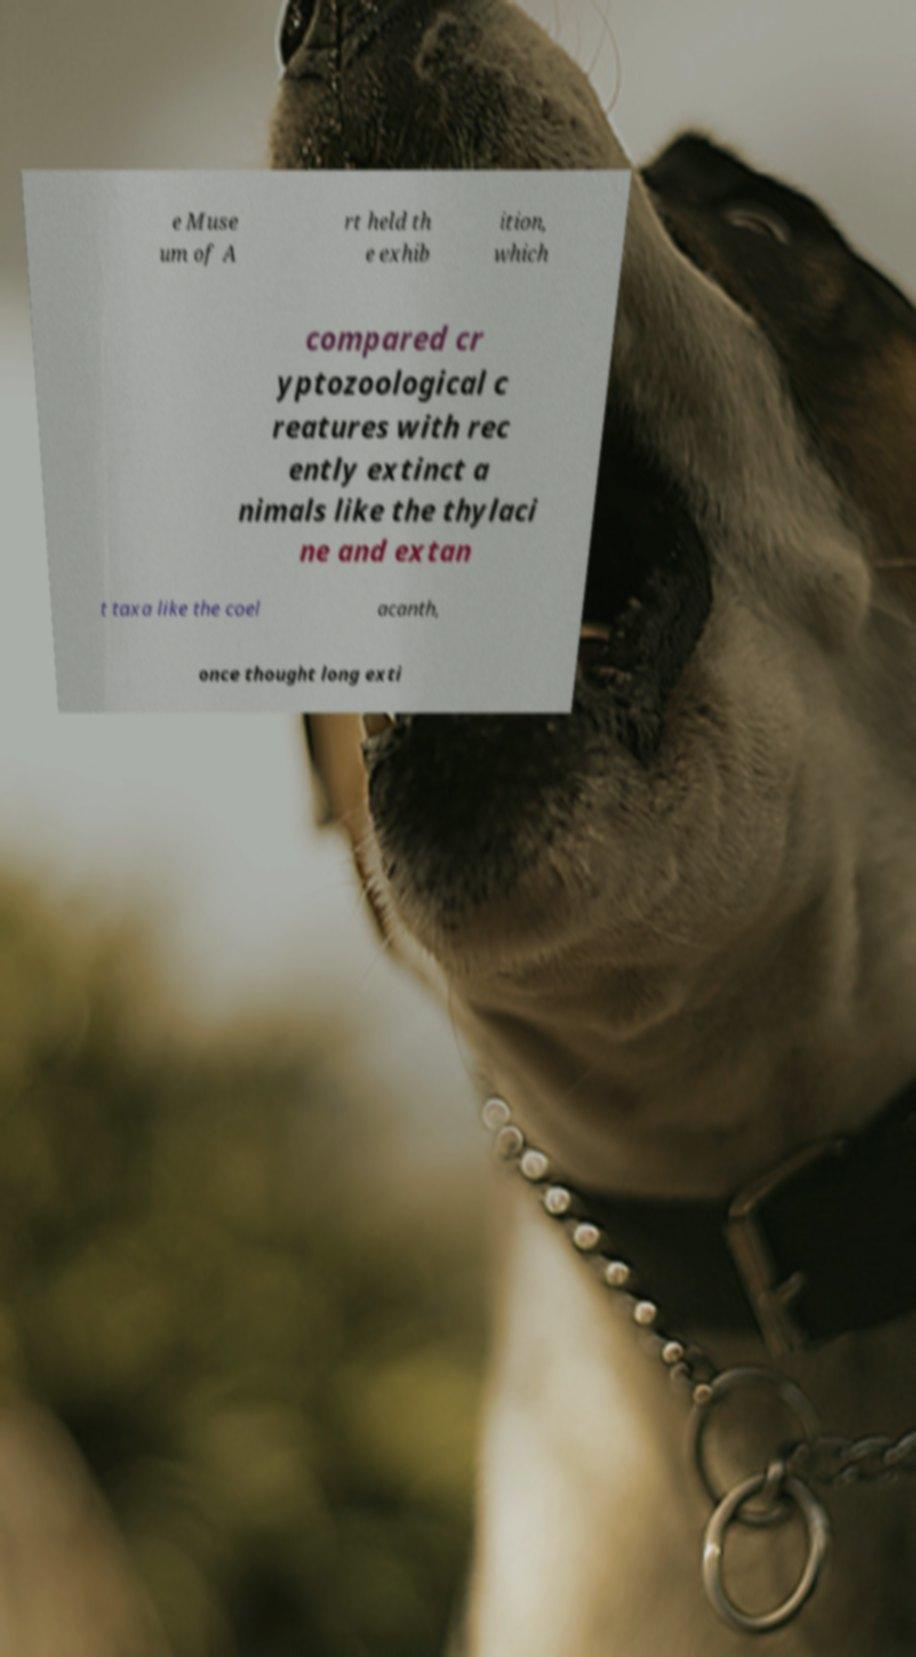What messages or text are displayed in this image? I need them in a readable, typed format. e Muse um of A rt held th e exhib ition, which compared cr yptozoological c reatures with rec ently extinct a nimals like the thylaci ne and extan t taxa like the coel acanth, once thought long exti 